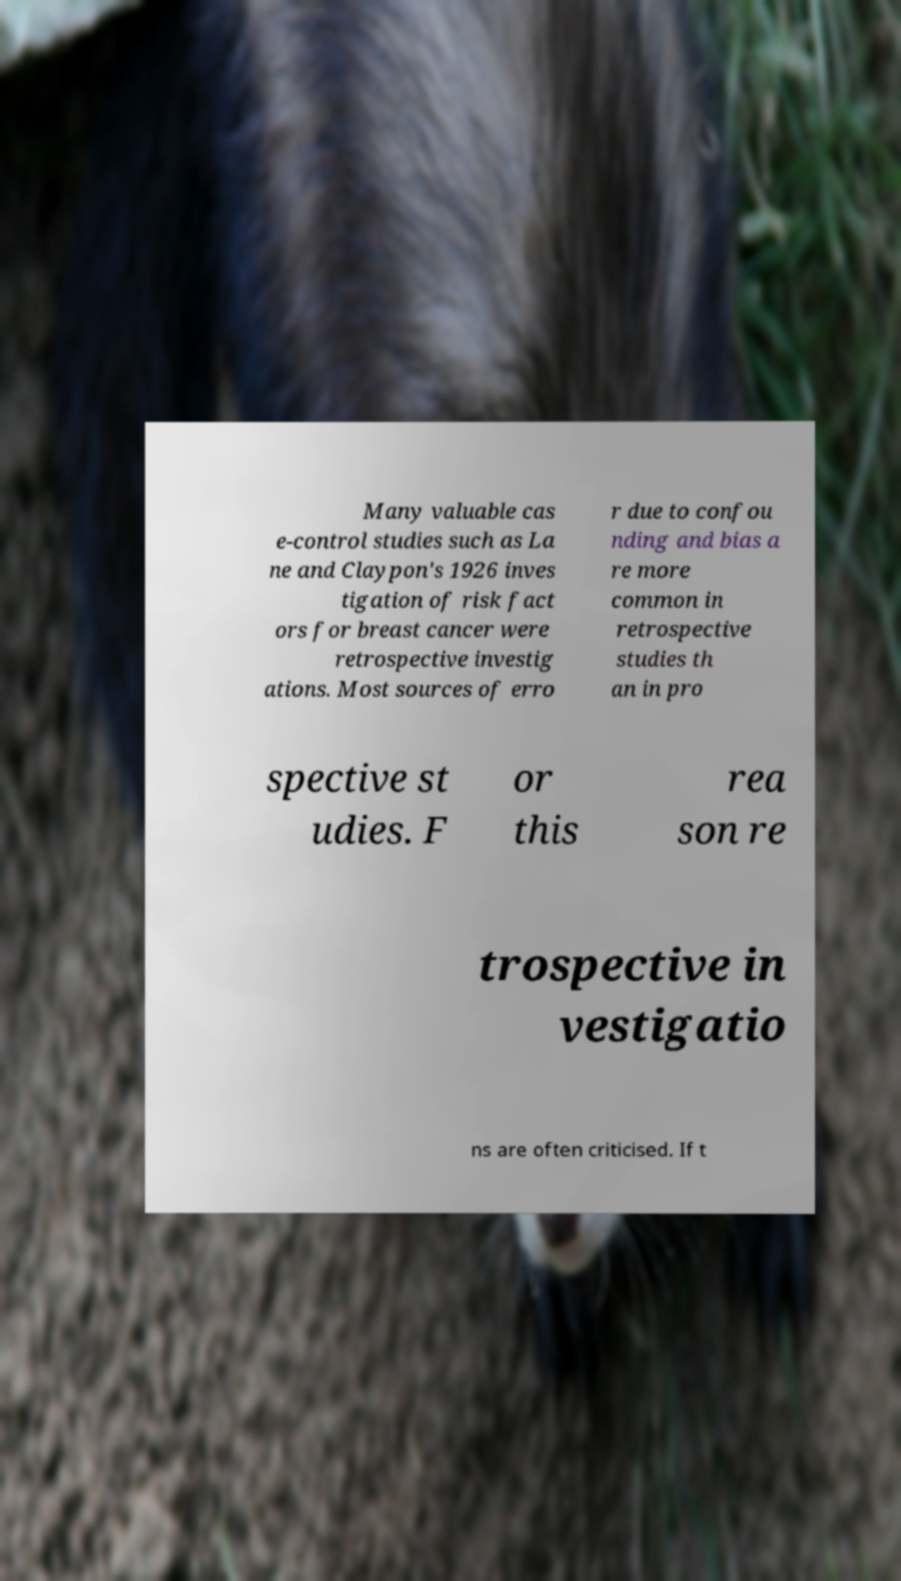For documentation purposes, I need the text within this image transcribed. Could you provide that? Many valuable cas e-control studies such as La ne and Claypon's 1926 inves tigation of risk fact ors for breast cancer were retrospective investig ations. Most sources of erro r due to confou nding and bias a re more common in retrospective studies th an in pro spective st udies. F or this rea son re trospective in vestigatio ns are often criticised. If t 